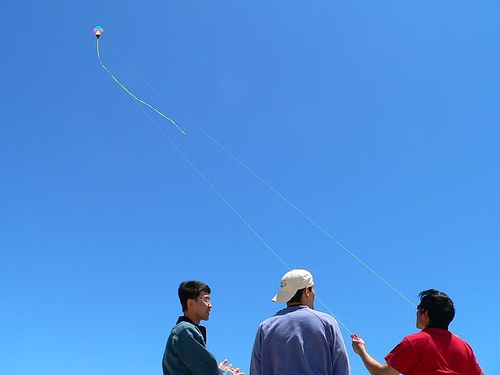Describe the objects in this image and their specific colors. I can see people in gray, navy, and darkgray tones, people in gray, maroon, black, and brown tones, people in gray, black, navy, maroon, and brown tones, and kite in gray, cyan, violet, and khaki tones in this image. 